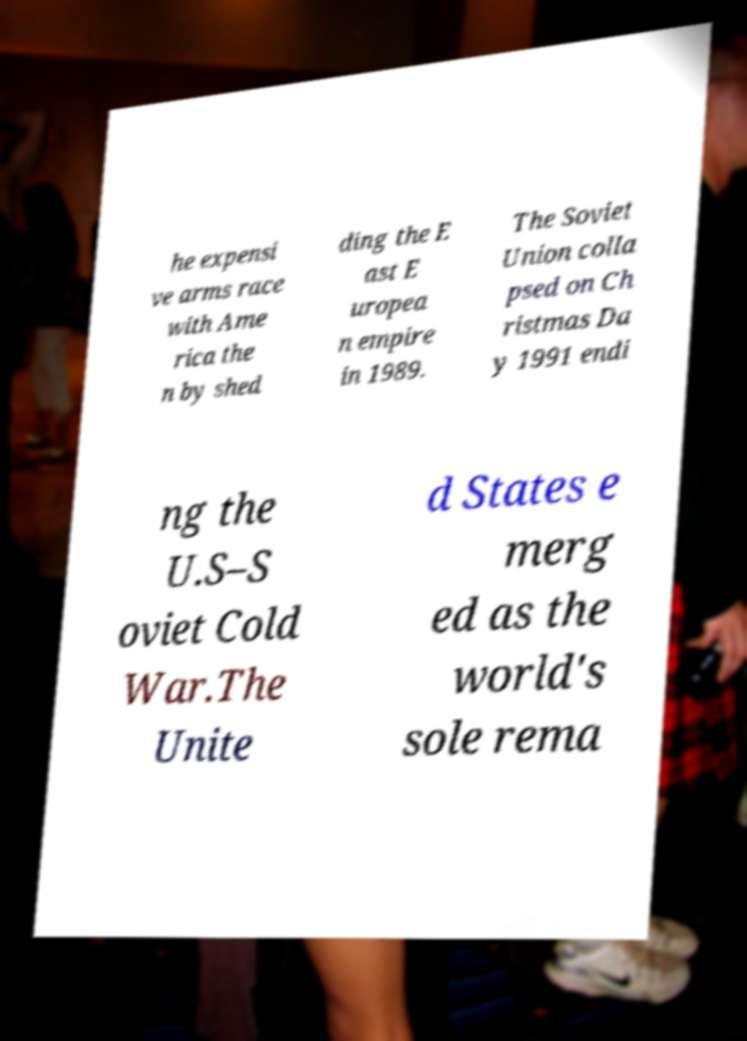Please identify and transcribe the text found in this image. he expensi ve arms race with Ame rica the n by shed ding the E ast E uropea n empire in 1989. The Soviet Union colla psed on Ch ristmas Da y 1991 endi ng the U.S–S oviet Cold War.The Unite d States e merg ed as the world's sole rema 